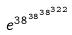Convert formula to latex. <formula><loc_0><loc_0><loc_500><loc_500>e ^ { 3 8 ^ { 3 8 ^ { 3 8 ^ { 3 2 2 } } } }</formula> 